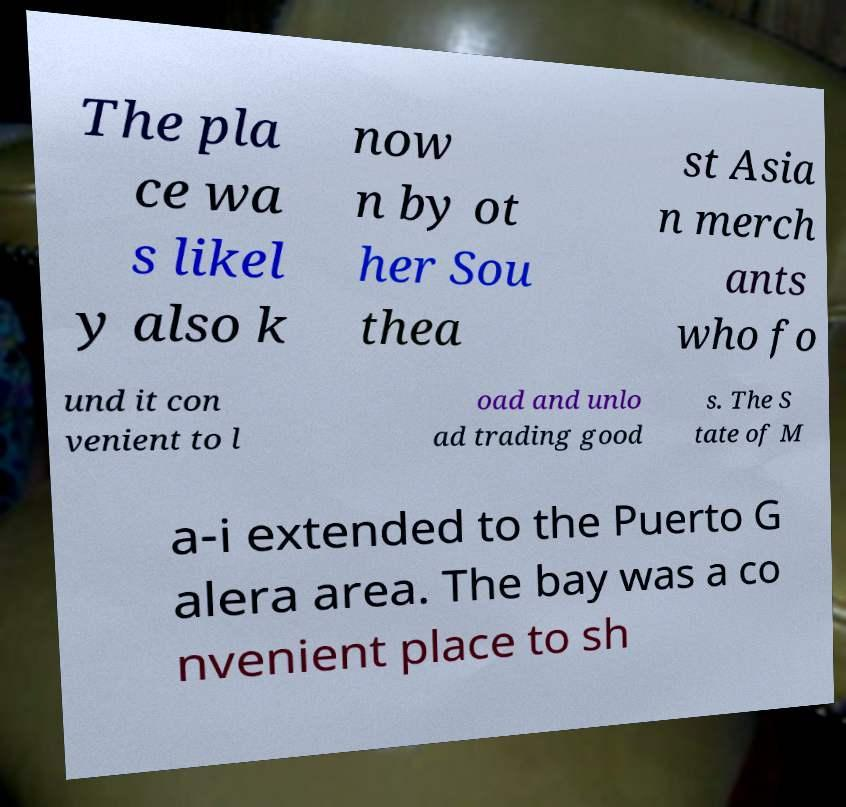Can you read and provide the text displayed in the image?This photo seems to have some interesting text. Can you extract and type it out for me? The pla ce wa s likel y also k now n by ot her Sou thea st Asia n merch ants who fo und it con venient to l oad and unlo ad trading good s. The S tate of M a-i extended to the Puerto G alera area. The bay was a co nvenient place to sh 